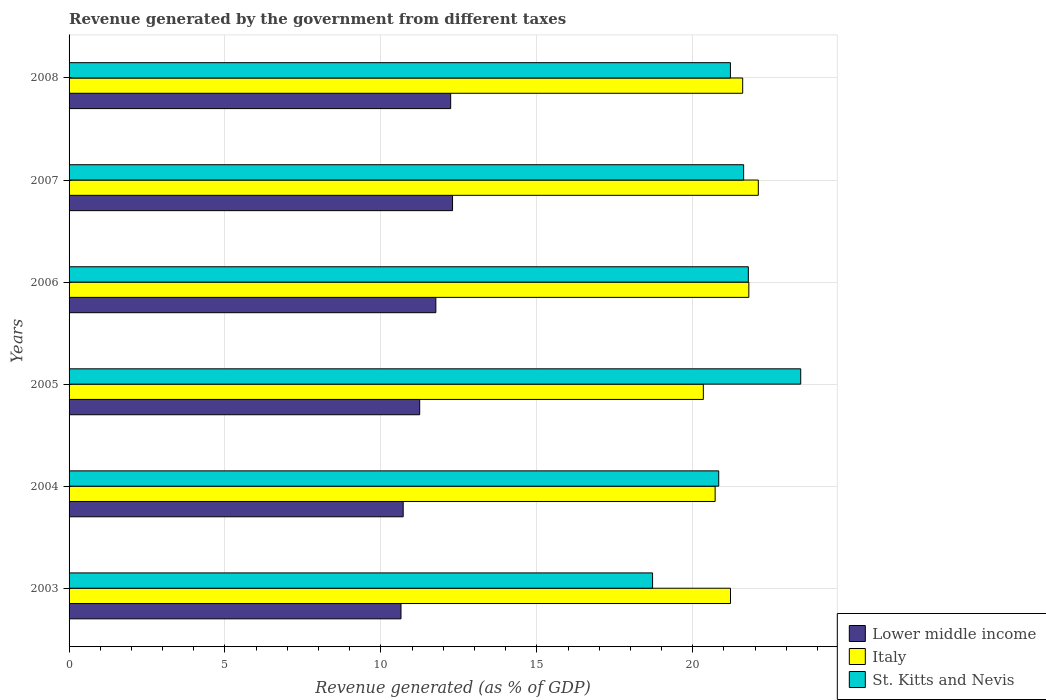Are the number of bars per tick equal to the number of legend labels?
Make the answer very short. Yes. Are the number of bars on each tick of the Y-axis equal?
Offer a very short reply. Yes. How many bars are there on the 3rd tick from the top?
Ensure brevity in your answer.  3. What is the revenue generated by the government in Italy in 2004?
Keep it short and to the point. 20.72. Across all years, what is the maximum revenue generated by the government in St. Kitts and Nevis?
Your answer should be very brief. 23.46. Across all years, what is the minimum revenue generated by the government in Italy?
Give a very brief answer. 20.34. In which year was the revenue generated by the government in Italy maximum?
Keep it short and to the point. 2007. What is the total revenue generated by the government in St. Kitts and Nevis in the graph?
Make the answer very short. 127.63. What is the difference between the revenue generated by the government in St. Kitts and Nevis in 2003 and that in 2008?
Ensure brevity in your answer.  -2.5. What is the difference between the revenue generated by the government in Italy in 2006 and the revenue generated by the government in St. Kitts and Nevis in 2008?
Make the answer very short. 0.59. What is the average revenue generated by the government in Lower middle income per year?
Give a very brief answer. 11.48. In the year 2008, what is the difference between the revenue generated by the government in Lower middle income and revenue generated by the government in St. Kitts and Nevis?
Keep it short and to the point. -8.97. What is the ratio of the revenue generated by the government in Lower middle income in 2007 to that in 2008?
Make the answer very short. 1. Is the revenue generated by the government in Italy in 2003 less than that in 2006?
Make the answer very short. Yes. Is the difference between the revenue generated by the government in Lower middle income in 2004 and 2006 greater than the difference between the revenue generated by the government in St. Kitts and Nevis in 2004 and 2006?
Your answer should be very brief. No. What is the difference between the highest and the second highest revenue generated by the government in Italy?
Keep it short and to the point. 0.3. What is the difference between the highest and the lowest revenue generated by the government in Lower middle income?
Keep it short and to the point. 1.65. Is the sum of the revenue generated by the government in St. Kitts and Nevis in 2006 and 2007 greater than the maximum revenue generated by the government in Italy across all years?
Make the answer very short. Yes. What does the 2nd bar from the bottom in 2008 represents?
Your answer should be very brief. Italy. How many years are there in the graph?
Offer a very short reply. 6. What is the difference between two consecutive major ticks on the X-axis?
Your answer should be very brief. 5. Does the graph contain any zero values?
Give a very brief answer. No. What is the title of the graph?
Offer a terse response. Revenue generated by the government from different taxes. What is the label or title of the X-axis?
Your answer should be compact. Revenue generated (as % of GDP). What is the Revenue generated (as % of GDP) of Lower middle income in 2003?
Ensure brevity in your answer.  10.64. What is the Revenue generated (as % of GDP) of Italy in 2003?
Provide a short and direct response. 21.21. What is the Revenue generated (as % of GDP) of St. Kitts and Nevis in 2003?
Keep it short and to the point. 18.71. What is the Revenue generated (as % of GDP) of Lower middle income in 2004?
Provide a succinct answer. 10.71. What is the Revenue generated (as % of GDP) in Italy in 2004?
Ensure brevity in your answer.  20.72. What is the Revenue generated (as % of GDP) in St. Kitts and Nevis in 2004?
Keep it short and to the point. 20.83. What is the Revenue generated (as % of GDP) in Lower middle income in 2005?
Keep it short and to the point. 11.24. What is the Revenue generated (as % of GDP) in Italy in 2005?
Provide a succinct answer. 20.34. What is the Revenue generated (as % of GDP) of St. Kitts and Nevis in 2005?
Make the answer very short. 23.46. What is the Revenue generated (as % of GDP) in Lower middle income in 2006?
Provide a short and direct response. 11.76. What is the Revenue generated (as % of GDP) of Italy in 2006?
Your response must be concise. 21.8. What is the Revenue generated (as % of GDP) of St. Kitts and Nevis in 2006?
Provide a succinct answer. 21.78. What is the Revenue generated (as % of GDP) in Lower middle income in 2007?
Offer a terse response. 12.3. What is the Revenue generated (as % of GDP) of Italy in 2007?
Offer a terse response. 22.1. What is the Revenue generated (as % of GDP) of St. Kitts and Nevis in 2007?
Make the answer very short. 21.63. What is the Revenue generated (as % of GDP) in Lower middle income in 2008?
Make the answer very short. 12.24. What is the Revenue generated (as % of GDP) of Italy in 2008?
Ensure brevity in your answer.  21.6. What is the Revenue generated (as % of GDP) in St. Kitts and Nevis in 2008?
Offer a very short reply. 21.21. Across all years, what is the maximum Revenue generated (as % of GDP) in Lower middle income?
Give a very brief answer. 12.3. Across all years, what is the maximum Revenue generated (as % of GDP) of Italy?
Your answer should be very brief. 22.1. Across all years, what is the maximum Revenue generated (as % of GDP) in St. Kitts and Nevis?
Keep it short and to the point. 23.46. Across all years, what is the minimum Revenue generated (as % of GDP) of Lower middle income?
Provide a short and direct response. 10.64. Across all years, what is the minimum Revenue generated (as % of GDP) in Italy?
Keep it short and to the point. 20.34. Across all years, what is the minimum Revenue generated (as % of GDP) in St. Kitts and Nevis?
Your response must be concise. 18.71. What is the total Revenue generated (as % of GDP) in Lower middle income in the graph?
Provide a succinct answer. 68.9. What is the total Revenue generated (as % of GDP) of Italy in the graph?
Give a very brief answer. 127.77. What is the total Revenue generated (as % of GDP) in St. Kitts and Nevis in the graph?
Offer a terse response. 127.63. What is the difference between the Revenue generated (as % of GDP) of Lower middle income in 2003 and that in 2004?
Give a very brief answer. -0.07. What is the difference between the Revenue generated (as % of GDP) of Italy in 2003 and that in 2004?
Offer a very short reply. 0.49. What is the difference between the Revenue generated (as % of GDP) of St. Kitts and Nevis in 2003 and that in 2004?
Your response must be concise. -2.12. What is the difference between the Revenue generated (as % of GDP) of Lower middle income in 2003 and that in 2005?
Your answer should be very brief. -0.6. What is the difference between the Revenue generated (as % of GDP) of Italy in 2003 and that in 2005?
Keep it short and to the point. 0.87. What is the difference between the Revenue generated (as % of GDP) in St. Kitts and Nevis in 2003 and that in 2005?
Keep it short and to the point. -4.75. What is the difference between the Revenue generated (as % of GDP) of Lower middle income in 2003 and that in 2006?
Give a very brief answer. -1.12. What is the difference between the Revenue generated (as % of GDP) of Italy in 2003 and that in 2006?
Your answer should be compact. -0.59. What is the difference between the Revenue generated (as % of GDP) of St. Kitts and Nevis in 2003 and that in 2006?
Make the answer very short. -3.07. What is the difference between the Revenue generated (as % of GDP) in Lower middle income in 2003 and that in 2007?
Provide a succinct answer. -1.65. What is the difference between the Revenue generated (as % of GDP) of Italy in 2003 and that in 2007?
Offer a terse response. -0.89. What is the difference between the Revenue generated (as % of GDP) in St. Kitts and Nevis in 2003 and that in 2007?
Keep it short and to the point. -2.92. What is the difference between the Revenue generated (as % of GDP) of Lower middle income in 2003 and that in 2008?
Offer a terse response. -1.59. What is the difference between the Revenue generated (as % of GDP) in Italy in 2003 and that in 2008?
Offer a very short reply. -0.39. What is the difference between the Revenue generated (as % of GDP) of St. Kitts and Nevis in 2003 and that in 2008?
Keep it short and to the point. -2.5. What is the difference between the Revenue generated (as % of GDP) of Lower middle income in 2004 and that in 2005?
Offer a terse response. -0.53. What is the difference between the Revenue generated (as % of GDP) in Italy in 2004 and that in 2005?
Your response must be concise. 0.38. What is the difference between the Revenue generated (as % of GDP) in St. Kitts and Nevis in 2004 and that in 2005?
Provide a succinct answer. -2.63. What is the difference between the Revenue generated (as % of GDP) in Lower middle income in 2004 and that in 2006?
Ensure brevity in your answer.  -1.05. What is the difference between the Revenue generated (as % of GDP) in Italy in 2004 and that in 2006?
Your answer should be very brief. -1.08. What is the difference between the Revenue generated (as % of GDP) of St. Kitts and Nevis in 2004 and that in 2006?
Your answer should be compact. -0.95. What is the difference between the Revenue generated (as % of GDP) in Lower middle income in 2004 and that in 2007?
Offer a terse response. -1.58. What is the difference between the Revenue generated (as % of GDP) of Italy in 2004 and that in 2007?
Give a very brief answer. -1.38. What is the difference between the Revenue generated (as % of GDP) in St. Kitts and Nevis in 2004 and that in 2007?
Your answer should be very brief. -0.8. What is the difference between the Revenue generated (as % of GDP) in Lower middle income in 2004 and that in 2008?
Give a very brief answer. -1.52. What is the difference between the Revenue generated (as % of GDP) of Italy in 2004 and that in 2008?
Your answer should be very brief. -0.88. What is the difference between the Revenue generated (as % of GDP) in St. Kitts and Nevis in 2004 and that in 2008?
Your answer should be compact. -0.38. What is the difference between the Revenue generated (as % of GDP) of Lower middle income in 2005 and that in 2006?
Your answer should be compact. -0.52. What is the difference between the Revenue generated (as % of GDP) in Italy in 2005 and that in 2006?
Offer a very short reply. -1.46. What is the difference between the Revenue generated (as % of GDP) in St. Kitts and Nevis in 2005 and that in 2006?
Give a very brief answer. 1.68. What is the difference between the Revenue generated (as % of GDP) of Lower middle income in 2005 and that in 2007?
Your answer should be compact. -1.05. What is the difference between the Revenue generated (as % of GDP) in Italy in 2005 and that in 2007?
Provide a short and direct response. -1.76. What is the difference between the Revenue generated (as % of GDP) of St. Kitts and Nevis in 2005 and that in 2007?
Offer a terse response. 1.83. What is the difference between the Revenue generated (as % of GDP) in Lower middle income in 2005 and that in 2008?
Your response must be concise. -0.99. What is the difference between the Revenue generated (as % of GDP) in Italy in 2005 and that in 2008?
Make the answer very short. -1.26. What is the difference between the Revenue generated (as % of GDP) in St. Kitts and Nevis in 2005 and that in 2008?
Your answer should be compact. 2.25. What is the difference between the Revenue generated (as % of GDP) in Lower middle income in 2006 and that in 2007?
Give a very brief answer. -0.54. What is the difference between the Revenue generated (as % of GDP) of Italy in 2006 and that in 2007?
Give a very brief answer. -0.3. What is the difference between the Revenue generated (as % of GDP) in St. Kitts and Nevis in 2006 and that in 2007?
Your answer should be very brief. 0.15. What is the difference between the Revenue generated (as % of GDP) of Lower middle income in 2006 and that in 2008?
Give a very brief answer. -0.48. What is the difference between the Revenue generated (as % of GDP) of Italy in 2006 and that in 2008?
Provide a short and direct response. 0.2. What is the difference between the Revenue generated (as % of GDP) in St. Kitts and Nevis in 2006 and that in 2008?
Give a very brief answer. 0.57. What is the difference between the Revenue generated (as % of GDP) in Lower middle income in 2007 and that in 2008?
Offer a very short reply. 0.06. What is the difference between the Revenue generated (as % of GDP) of Italy in 2007 and that in 2008?
Your answer should be very brief. 0.5. What is the difference between the Revenue generated (as % of GDP) of St. Kitts and Nevis in 2007 and that in 2008?
Your answer should be very brief. 0.42. What is the difference between the Revenue generated (as % of GDP) of Lower middle income in 2003 and the Revenue generated (as % of GDP) of Italy in 2004?
Make the answer very short. -10.07. What is the difference between the Revenue generated (as % of GDP) in Lower middle income in 2003 and the Revenue generated (as % of GDP) in St. Kitts and Nevis in 2004?
Your answer should be compact. -10.19. What is the difference between the Revenue generated (as % of GDP) in Italy in 2003 and the Revenue generated (as % of GDP) in St. Kitts and Nevis in 2004?
Your answer should be compact. 0.38. What is the difference between the Revenue generated (as % of GDP) in Lower middle income in 2003 and the Revenue generated (as % of GDP) in Italy in 2005?
Provide a succinct answer. -9.7. What is the difference between the Revenue generated (as % of GDP) of Lower middle income in 2003 and the Revenue generated (as % of GDP) of St. Kitts and Nevis in 2005?
Make the answer very short. -12.82. What is the difference between the Revenue generated (as % of GDP) in Italy in 2003 and the Revenue generated (as % of GDP) in St. Kitts and Nevis in 2005?
Offer a very short reply. -2.25. What is the difference between the Revenue generated (as % of GDP) of Lower middle income in 2003 and the Revenue generated (as % of GDP) of Italy in 2006?
Offer a very short reply. -11.15. What is the difference between the Revenue generated (as % of GDP) of Lower middle income in 2003 and the Revenue generated (as % of GDP) of St. Kitts and Nevis in 2006?
Provide a short and direct response. -11.14. What is the difference between the Revenue generated (as % of GDP) of Italy in 2003 and the Revenue generated (as % of GDP) of St. Kitts and Nevis in 2006?
Provide a short and direct response. -0.57. What is the difference between the Revenue generated (as % of GDP) of Lower middle income in 2003 and the Revenue generated (as % of GDP) of Italy in 2007?
Keep it short and to the point. -11.46. What is the difference between the Revenue generated (as % of GDP) in Lower middle income in 2003 and the Revenue generated (as % of GDP) in St. Kitts and Nevis in 2007?
Offer a terse response. -10.99. What is the difference between the Revenue generated (as % of GDP) in Italy in 2003 and the Revenue generated (as % of GDP) in St. Kitts and Nevis in 2007?
Your response must be concise. -0.42. What is the difference between the Revenue generated (as % of GDP) in Lower middle income in 2003 and the Revenue generated (as % of GDP) in Italy in 2008?
Ensure brevity in your answer.  -10.96. What is the difference between the Revenue generated (as % of GDP) of Lower middle income in 2003 and the Revenue generated (as % of GDP) of St. Kitts and Nevis in 2008?
Provide a short and direct response. -10.56. What is the difference between the Revenue generated (as % of GDP) of Italy in 2003 and the Revenue generated (as % of GDP) of St. Kitts and Nevis in 2008?
Your answer should be compact. 0. What is the difference between the Revenue generated (as % of GDP) of Lower middle income in 2004 and the Revenue generated (as % of GDP) of Italy in 2005?
Offer a very short reply. -9.63. What is the difference between the Revenue generated (as % of GDP) of Lower middle income in 2004 and the Revenue generated (as % of GDP) of St. Kitts and Nevis in 2005?
Keep it short and to the point. -12.75. What is the difference between the Revenue generated (as % of GDP) of Italy in 2004 and the Revenue generated (as % of GDP) of St. Kitts and Nevis in 2005?
Your answer should be compact. -2.74. What is the difference between the Revenue generated (as % of GDP) in Lower middle income in 2004 and the Revenue generated (as % of GDP) in Italy in 2006?
Make the answer very short. -11.08. What is the difference between the Revenue generated (as % of GDP) of Lower middle income in 2004 and the Revenue generated (as % of GDP) of St. Kitts and Nevis in 2006?
Your response must be concise. -11.07. What is the difference between the Revenue generated (as % of GDP) of Italy in 2004 and the Revenue generated (as % of GDP) of St. Kitts and Nevis in 2006?
Give a very brief answer. -1.06. What is the difference between the Revenue generated (as % of GDP) of Lower middle income in 2004 and the Revenue generated (as % of GDP) of Italy in 2007?
Make the answer very short. -11.39. What is the difference between the Revenue generated (as % of GDP) in Lower middle income in 2004 and the Revenue generated (as % of GDP) in St. Kitts and Nevis in 2007?
Your response must be concise. -10.92. What is the difference between the Revenue generated (as % of GDP) in Italy in 2004 and the Revenue generated (as % of GDP) in St. Kitts and Nevis in 2007?
Ensure brevity in your answer.  -0.91. What is the difference between the Revenue generated (as % of GDP) of Lower middle income in 2004 and the Revenue generated (as % of GDP) of Italy in 2008?
Provide a succinct answer. -10.89. What is the difference between the Revenue generated (as % of GDP) in Lower middle income in 2004 and the Revenue generated (as % of GDP) in St. Kitts and Nevis in 2008?
Provide a short and direct response. -10.49. What is the difference between the Revenue generated (as % of GDP) in Italy in 2004 and the Revenue generated (as % of GDP) in St. Kitts and Nevis in 2008?
Offer a very short reply. -0.49. What is the difference between the Revenue generated (as % of GDP) in Lower middle income in 2005 and the Revenue generated (as % of GDP) in Italy in 2006?
Offer a terse response. -10.55. What is the difference between the Revenue generated (as % of GDP) in Lower middle income in 2005 and the Revenue generated (as % of GDP) in St. Kitts and Nevis in 2006?
Offer a very short reply. -10.54. What is the difference between the Revenue generated (as % of GDP) of Italy in 2005 and the Revenue generated (as % of GDP) of St. Kitts and Nevis in 2006?
Provide a succinct answer. -1.44. What is the difference between the Revenue generated (as % of GDP) in Lower middle income in 2005 and the Revenue generated (as % of GDP) in Italy in 2007?
Offer a very short reply. -10.86. What is the difference between the Revenue generated (as % of GDP) of Lower middle income in 2005 and the Revenue generated (as % of GDP) of St. Kitts and Nevis in 2007?
Your answer should be compact. -10.39. What is the difference between the Revenue generated (as % of GDP) in Italy in 2005 and the Revenue generated (as % of GDP) in St. Kitts and Nevis in 2007?
Your response must be concise. -1.29. What is the difference between the Revenue generated (as % of GDP) in Lower middle income in 2005 and the Revenue generated (as % of GDP) in Italy in 2008?
Offer a very short reply. -10.36. What is the difference between the Revenue generated (as % of GDP) of Lower middle income in 2005 and the Revenue generated (as % of GDP) of St. Kitts and Nevis in 2008?
Your response must be concise. -9.97. What is the difference between the Revenue generated (as % of GDP) of Italy in 2005 and the Revenue generated (as % of GDP) of St. Kitts and Nevis in 2008?
Your answer should be very brief. -0.87. What is the difference between the Revenue generated (as % of GDP) in Lower middle income in 2006 and the Revenue generated (as % of GDP) in Italy in 2007?
Your response must be concise. -10.34. What is the difference between the Revenue generated (as % of GDP) in Lower middle income in 2006 and the Revenue generated (as % of GDP) in St. Kitts and Nevis in 2007?
Make the answer very short. -9.87. What is the difference between the Revenue generated (as % of GDP) of Italy in 2006 and the Revenue generated (as % of GDP) of St. Kitts and Nevis in 2007?
Your response must be concise. 0.17. What is the difference between the Revenue generated (as % of GDP) of Lower middle income in 2006 and the Revenue generated (as % of GDP) of Italy in 2008?
Ensure brevity in your answer.  -9.84. What is the difference between the Revenue generated (as % of GDP) of Lower middle income in 2006 and the Revenue generated (as % of GDP) of St. Kitts and Nevis in 2008?
Make the answer very short. -9.45. What is the difference between the Revenue generated (as % of GDP) of Italy in 2006 and the Revenue generated (as % of GDP) of St. Kitts and Nevis in 2008?
Ensure brevity in your answer.  0.59. What is the difference between the Revenue generated (as % of GDP) of Lower middle income in 2007 and the Revenue generated (as % of GDP) of Italy in 2008?
Make the answer very short. -9.3. What is the difference between the Revenue generated (as % of GDP) in Lower middle income in 2007 and the Revenue generated (as % of GDP) in St. Kitts and Nevis in 2008?
Offer a terse response. -8.91. What is the difference between the Revenue generated (as % of GDP) in Italy in 2007 and the Revenue generated (as % of GDP) in St. Kitts and Nevis in 2008?
Your response must be concise. 0.89. What is the average Revenue generated (as % of GDP) of Lower middle income per year?
Your answer should be compact. 11.48. What is the average Revenue generated (as % of GDP) in Italy per year?
Offer a terse response. 21.3. What is the average Revenue generated (as % of GDP) of St. Kitts and Nevis per year?
Make the answer very short. 21.27. In the year 2003, what is the difference between the Revenue generated (as % of GDP) in Lower middle income and Revenue generated (as % of GDP) in Italy?
Make the answer very short. -10.57. In the year 2003, what is the difference between the Revenue generated (as % of GDP) of Lower middle income and Revenue generated (as % of GDP) of St. Kitts and Nevis?
Ensure brevity in your answer.  -8.07. In the year 2003, what is the difference between the Revenue generated (as % of GDP) of Italy and Revenue generated (as % of GDP) of St. Kitts and Nevis?
Your answer should be compact. 2.5. In the year 2004, what is the difference between the Revenue generated (as % of GDP) of Lower middle income and Revenue generated (as % of GDP) of Italy?
Give a very brief answer. -10. In the year 2004, what is the difference between the Revenue generated (as % of GDP) in Lower middle income and Revenue generated (as % of GDP) in St. Kitts and Nevis?
Offer a terse response. -10.12. In the year 2004, what is the difference between the Revenue generated (as % of GDP) in Italy and Revenue generated (as % of GDP) in St. Kitts and Nevis?
Provide a short and direct response. -0.12. In the year 2005, what is the difference between the Revenue generated (as % of GDP) in Lower middle income and Revenue generated (as % of GDP) in Italy?
Provide a short and direct response. -9.1. In the year 2005, what is the difference between the Revenue generated (as % of GDP) of Lower middle income and Revenue generated (as % of GDP) of St. Kitts and Nevis?
Keep it short and to the point. -12.22. In the year 2005, what is the difference between the Revenue generated (as % of GDP) in Italy and Revenue generated (as % of GDP) in St. Kitts and Nevis?
Provide a short and direct response. -3.12. In the year 2006, what is the difference between the Revenue generated (as % of GDP) in Lower middle income and Revenue generated (as % of GDP) in Italy?
Provide a succinct answer. -10.04. In the year 2006, what is the difference between the Revenue generated (as % of GDP) in Lower middle income and Revenue generated (as % of GDP) in St. Kitts and Nevis?
Keep it short and to the point. -10.02. In the year 2006, what is the difference between the Revenue generated (as % of GDP) in Italy and Revenue generated (as % of GDP) in St. Kitts and Nevis?
Your response must be concise. 0.02. In the year 2007, what is the difference between the Revenue generated (as % of GDP) of Lower middle income and Revenue generated (as % of GDP) of Italy?
Give a very brief answer. -9.81. In the year 2007, what is the difference between the Revenue generated (as % of GDP) in Lower middle income and Revenue generated (as % of GDP) in St. Kitts and Nevis?
Make the answer very short. -9.33. In the year 2007, what is the difference between the Revenue generated (as % of GDP) of Italy and Revenue generated (as % of GDP) of St. Kitts and Nevis?
Keep it short and to the point. 0.47. In the year 2008, what is the difference between the Revenue generated (as % of GDP) of Lower middle income and Revenue generated (as % of GDP) of Italy?
Offer a terse response. -9.36. In the year 2008, what is the difference between the Revenue generated (as % of GDP) of Lower middle income and Revenue generated (as % of GDP) of St. Kitts and Nevis?
Offer a terse response. -8.97. In the year 2008, what is the difference between the Revenue generated (as % of GDP) in Italy and Revenue generated (as % of GDP) in St. Kitts and Nevis?
Ensure brevity in your answer.  0.39. What is the ratio of the Revenue generated (as % of GDP) of Italy in 2003 to that in 2004?
Keep it short and to the point. 1.02. What is the ratio of the Revenue generated (as % of GDP) in St. Kitts and Nevis in 2003 to that in 2004?
Give a very brief answer. 0.9. What is the ratio of the Revenue generated (as % of GDP) of Lower middle income in 2003 to that in 2005?
Keep it short and to the point. 0.95. What is the ratio of the Revenue generated (as % of GDP) of Italy in 2003 to that in 2005?
Provide a short and direct response. 1.04. What is the ratio of the Revenue generated (as % of GDP) in St. Kitts and Nevis in 2003 to that in 2005?
Give a very brief answer. 0.8. What is the ratio of the Revenue generated (as % of GDP) in Lower middle income in 2003 to that in 2006?
Your answer should be compact. 0.91. What is the ratio of the Revenue generated (as % of GDP) in St. Kitts and Nevis in 2003 to that in 2006?
Provide a short and direct response. 0.86. What is the ratio of the Revenue generated (as % of GDP) in Lower middle income in 2003 to that in 2007?
Provide a succinct answer. 0.87. What is the ratio of the Revenue generated (as % of GDP) in Italy in 2003 to that in 2007?
Your answer should be compact. 0.96. What is the ratio of the Revenue generated (as % of GDP) of St. Kitts and Nevis in 2003 to that in 2007?
Keep it short and to the point. 0.86. What is the ratio of the Revenue generated (as % of GDP) of Lower middle income in 2003 to that in 2008?
Keep it short and to the point. 0.87. What is the ratio of the Revenue generated (as % of GDP) in Italy in 2003 to that in 2008?
Keep it short and to the point. 0.98. What is the ratio of the Revenue generated (as % of GDP) of St. Kitts and Nevis in 2003 to that in 2008?
Give a very brief answer. 0.88. What is the ratio of the Revenue generated (as % of GDP) of Lower middle income in 2004 to that in 2005?
Make the answer very short. 0.95. What is the ratio of the Revenue generated (as % of GDP) in Italy in 2004 to that in 2005?
Keep it short and to the point. 1.02. What is the ratio of the Revenue generated (as % of GDP) in St. Kitts and Nevis in 2004 to that in 2005?
Provide a short and direct response. 0.89. What is the ratio of the Revenue generated (as % of GDP) of Lower middle income in 2004 to that in 2006?
Give a very brief answer. 0.91. What is the ratio of the Revenue generated (as % of GDP) of Italy in 2004 to that in 2006?
Give a very brief answer. 0.95. What is the ratio of the Revenue generated (as % of GDP) of St. Kitts and Nevis in 2004 to that in 2006?
Ensure brevity in your answer.  0.96. What is the ratio of the Revenue generated (as % of GDP) in Lower middle income in 2004 to that in 2007?
Keep it short and to the point. 0.87. What is the ratio of the Revenue generated (as % of GDP) of Italy in 2004 to that in 2007?
Keep it short and to the point. 0.94. What is the ratio of the Revenue generated (as % of GDP) of St. Kitts and Nevis in 2004 to that in 2007?
Your answer should be very brief. 0.96. What is the ratio of the Revenue generated (as % of GDP) in Lower middle income in 2004 to that in 2008?
Offer a very short reply. 0.88. What is the ratio of the Revenue generated (as % of GDP) in Italy in 2004 to that in 2008?
Give a very brief answer. 0.96. What is the ratio of the Revenue generated (as % of GDP) of St. Kitts and Nevis in 2004 to that in 2008?
Your response must be concise. 0.98. What is the ratio of the Revenue generated (as % of GDP) in Lower middle income in 2005 to that in 2006?
Your answer should be very brief. 0.96. What is the ratio of the Revenue generated (as % of GDP) of Italy in 2005 to that in 2006?
Keep it short and to the point. 0.93. What is the ratio of the Revenue generated (as % of GDP) of St. Kitts and Nevis in 2005 to that in 2006?
Offer a very short reply. 1.08. What is the ratio of the Revenue generated (as % of GDP) of Lower middle income in 2005 to that in 2007?
Your answer should be compact. 0.91. What is the ratio of the Revenue generated (as % of GDP) in Italy in 2005 to that in 2007?
Your answer should be compact. 0.92. What is the ratio of the Revenue generated (as % of GDP) of St. Kitts and Nevis in 2005 to that in 2007?
Your answer should be very brief. 1.08. What is the ratio of the Revenue generated (as % of GDP) in Lower middle income in 2005 to that in 2008?
Keep it short and to the point. 0.92. What is the ratio of the Revenue generated (as % of GDP) in Italy in 2005 to that in 2008?
Offer a terse response. 0.94. What is the ratio of the Revenue generated (as % of GDP) of St. Kitts and Nevis in 2005 to that in 2008?
Offer a very short reply. 1.11. What is the ratio of the Revenue generated (as % of GDP) of Lower middle income in 2006 to that in 2007?
Your response must be concise. 0.96. What is the ratio of the Revenue generated (as % of GDP) of Italy in 2006 to that in 2007?
Give a very brief answer. 0.99. What is the ratio of the Revenue generated (as % of GDP) of St. Kitts and Nevis in 2006 to that in 2007?
Make the answer very short. 1.01. What is the ratio of the Revenue generated (as % of GDP) in Lower middle income in 2006 to that in 2008?
Your answer should be very brief. 0.96. What is the ratio of the Revenue generated (as % of GDP) of Italy in 2006 to that in 2008?
Your answer should be very brief. 1.01. What is the ratio of the Revenue generated (as % of GDP) of St. Kitts and Nevis in 2006 to that in 2008?
Give a very brief answer. 1.03. What is the ratio of the Revenue generated (as % of GDP) of Lower middle income in 2007 to that in 2008?
Your response must be concise. 1. What is the ratio of the Revenue generated (as % of GDP) of Italy in 2007 to that in 2008?
Offer a very short reply. 1.02. What is the ratio of the Revenue generated (as % of GDP) in St. Kitts and Nevis in 2007 to that in 2008?
Your response must be concise. 1.02. What is the difference between the highest and the second highest Revenue generated (as % of GDP) in Lower middle income?
Your response must be concise. 0.06. What is the difference between the highest and the second highest Revenue generated (as % of GDP) of Italy?
Give a very brief answer. 0.3. What is the difference between the highest and the second highest Revenue generated (as % of GDP) in St. Kitts and Nevis?
Offer a terse response. 1.68. What is the difference between the highest and the lowest Revenue generated (as % of GDP) in Lower middle income?
Provide a short and direct response. 1.65. What is the difference between the highest and the lowest Revenue generated (as % of GDP) of Italy?
Your response must be concise. 1.76. What is the difference between the highest and the lowest Revenue generated (as % of GDP) of St. Kitts and Nevis?
Offer a very short reply. 4.75. 